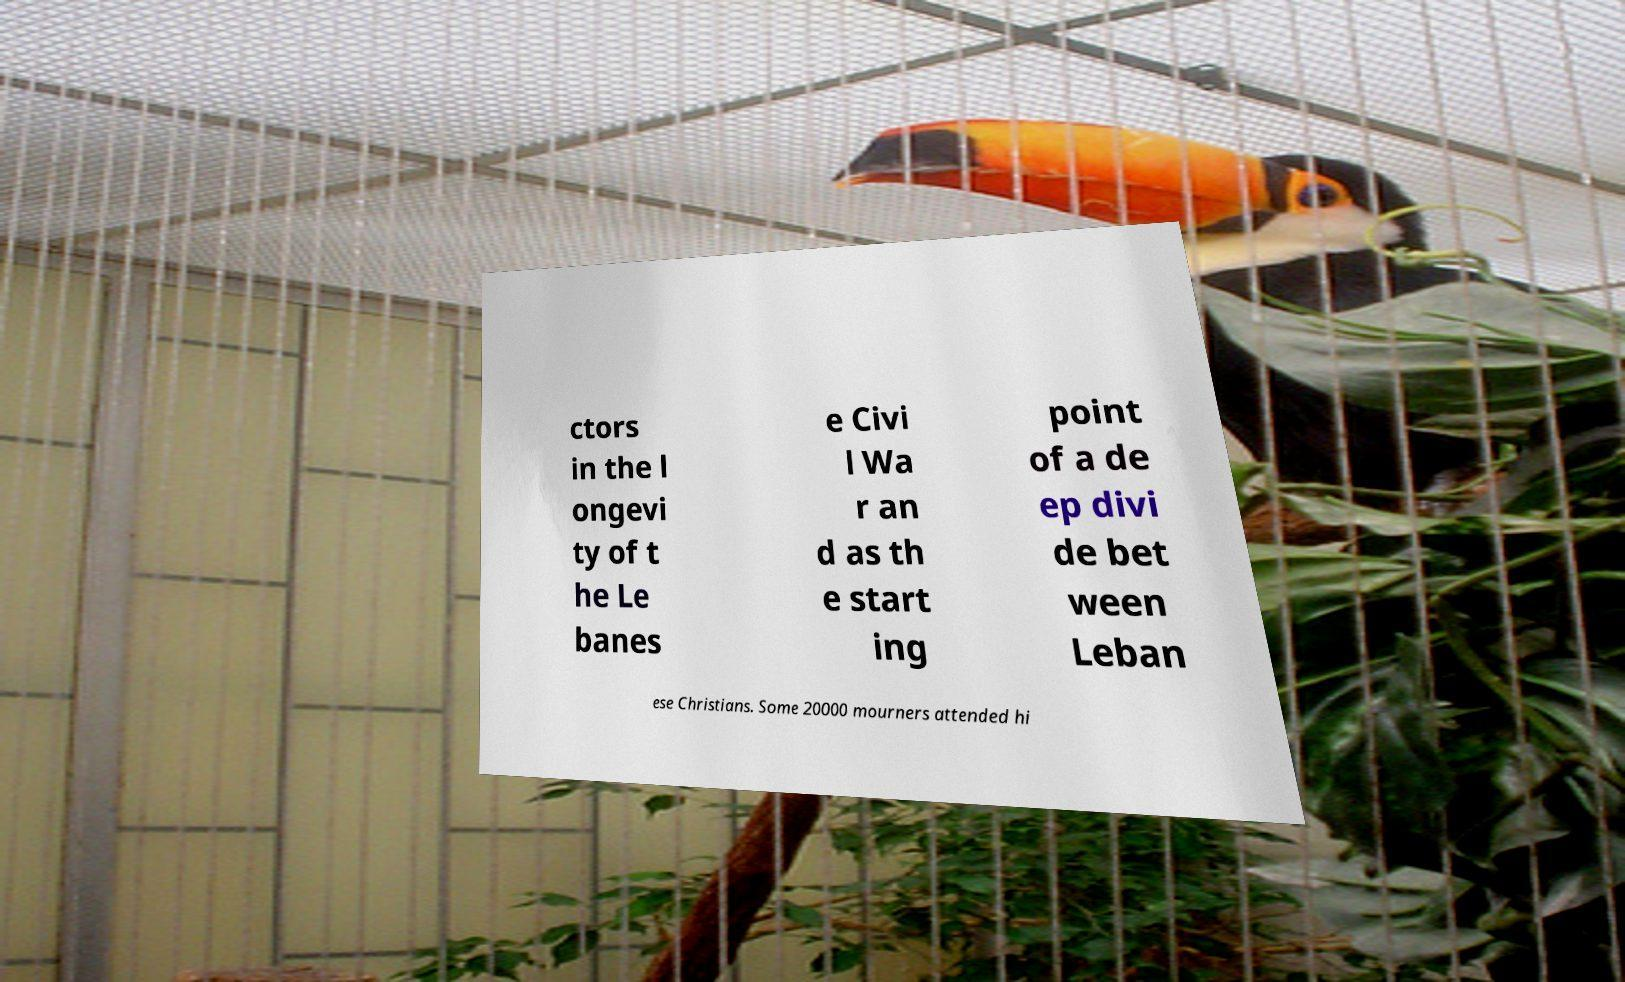Can you read and provide the text displayed in the image?This photo seems to have some interesting text. Can you extract and type it out for me? ctors in the l ongevi ty of t he Le banes e Civi l Wa r an d as th e start ing point of a de ep divi de bet ween Leban ese Christians. Some 20000 mourners attended hi 